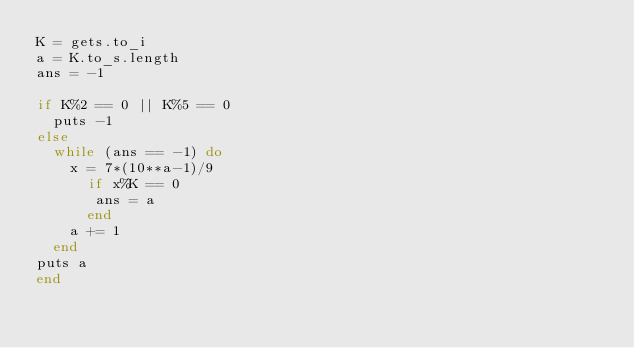Convert code to text. <code><loc_0><loc_0><loc_500><loc_500><_Ruby_>K = gets.to_i
a = K.to_s.length
ans = -1

if K%2 == 0 || K%5 == 0
  puts -1
else
  while (ans == -1) do 
    x = 7*(10**a-1)/9
      if x%K == 0
       ans = a
      end
    a += 1
  end
puts a
end

    
    </code> 